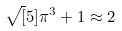Convert formula to latex. <formula><loc_0><loc_0><loc_500><loc_500>\sqrt { [ } 5 ] { \pi ^ { 3 } + 1 } \approx 2</formula> 